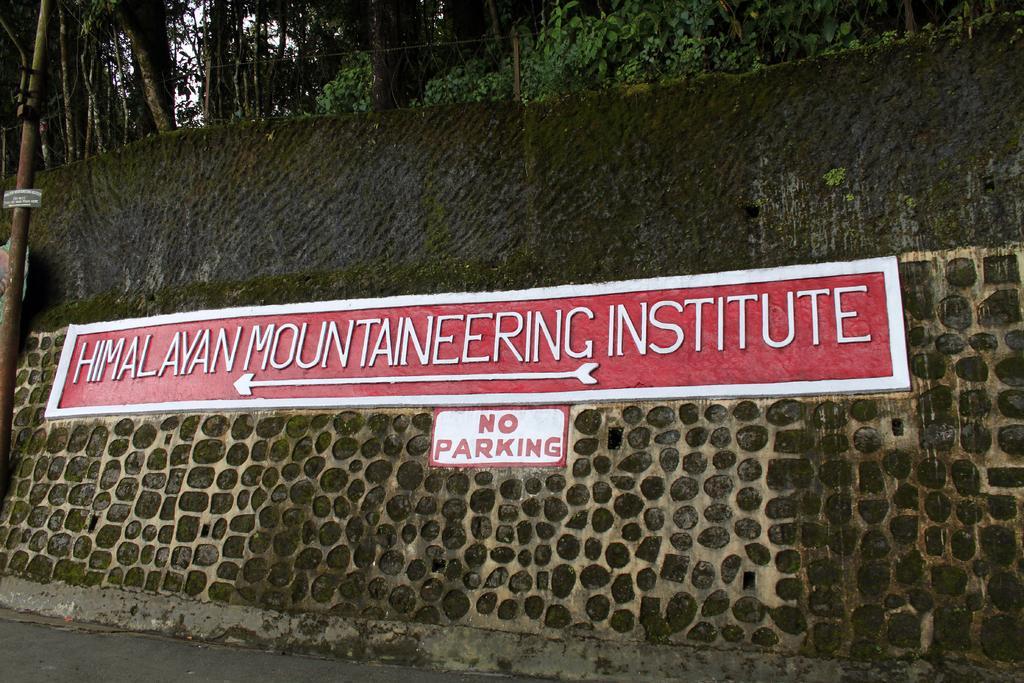Can you describe this image briefly? In this picture I can observe a wall. There is some text on the wall. On the left side I can observe a pole. In the background there are trees and plants on the ground. 